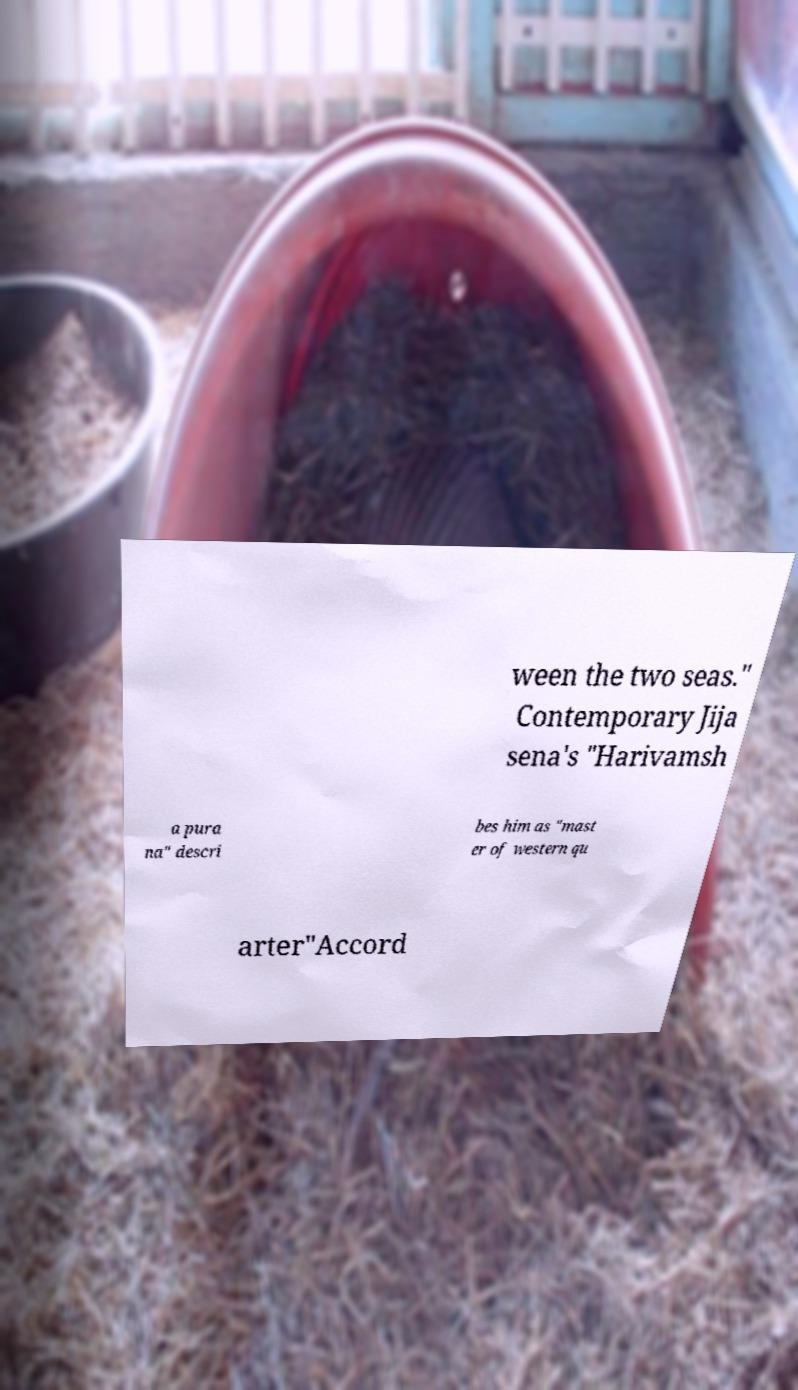Please identify and transcribe the text found in this image. ween the two seas." Contemporary Jija sena's "Harivamsh a pura na" descri bes him as "mast er of western qu arter"Accord 